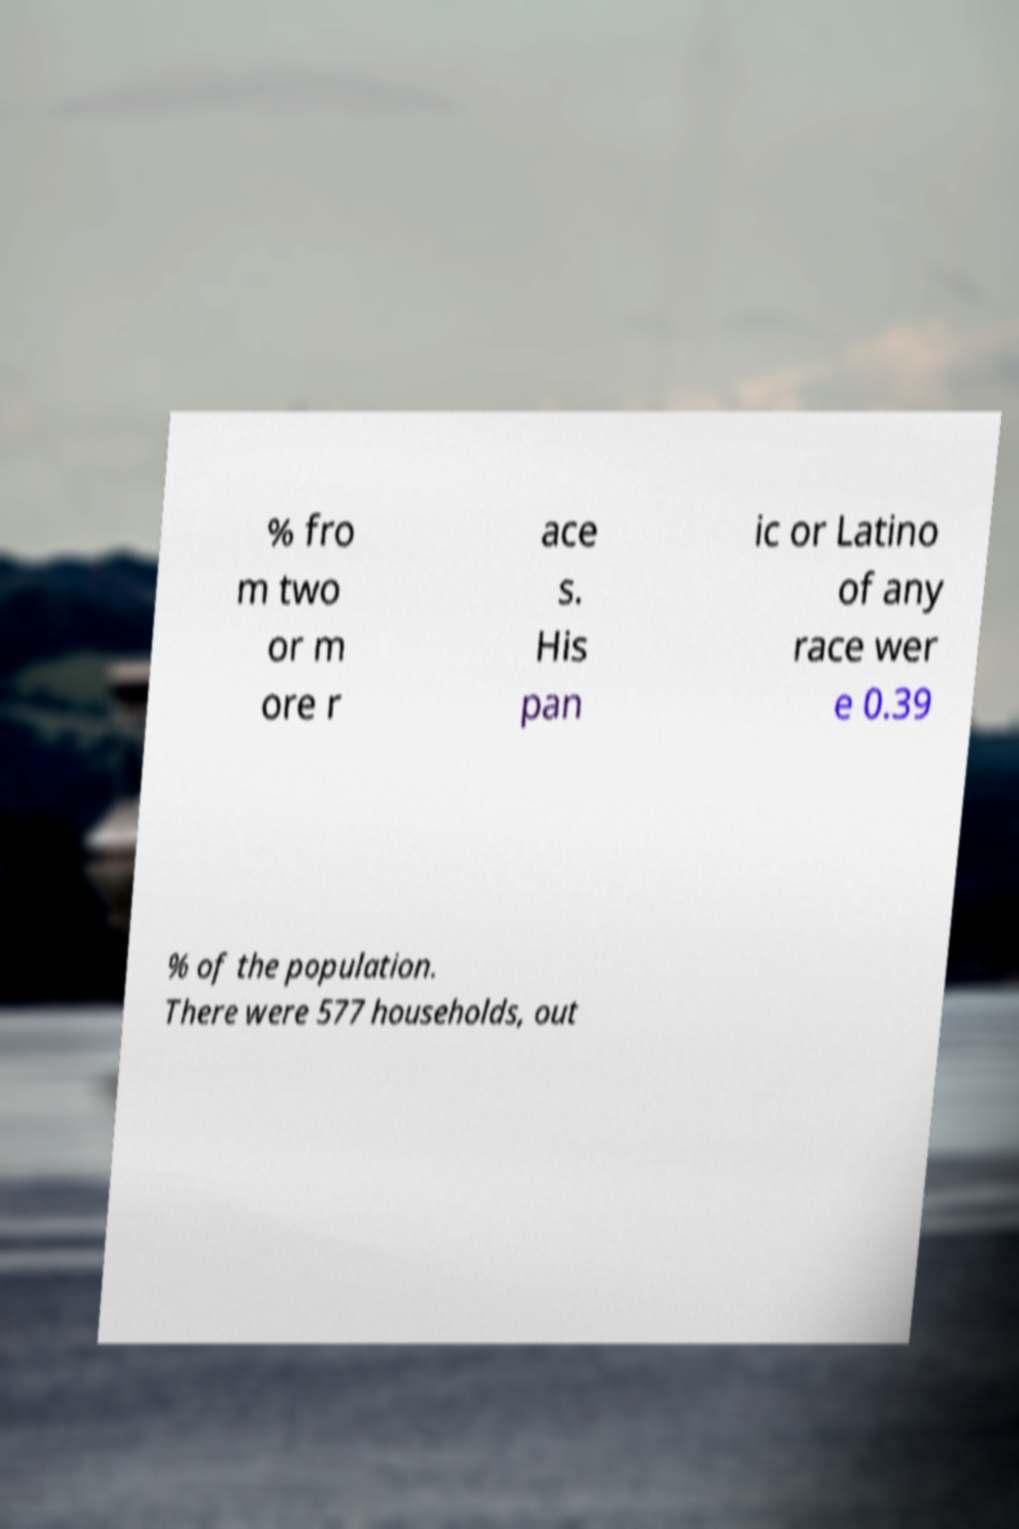Could you extract and type out the text from this image? % fro m two or m ore r ace s. His pan ic or Latino of any race wer e 0.39 % of the population. There were 577 households, out 